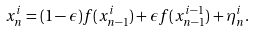<formula> <loc_0><loc_0><loc_500><loc_500>x _ { n } ^ { i } = ( 1 - \epsilon ) f ( x _ { n - 1 } ^ { i } ) + \epsilon f ( x _ { n - 1 } ^ { i - 1 } ) + \eta _ { n } ^ { i } .</formula> 